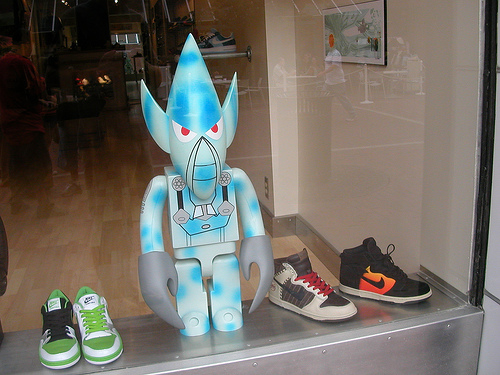<image>
Is there a shoe next to the shoe? No. The shoe is not positioned next to the shoe. They are located in different areas of the scene. Where is the shoe in relation to the floor? Is it above the floor? Yes. The shoe is positioned above the floor in the vertical space, higher up in the scene. Is there a robot on the shoe? No. The robot is not positioned on the shoe. They may be near each other, but the robot is not supported by or resting on top of the shoe. 